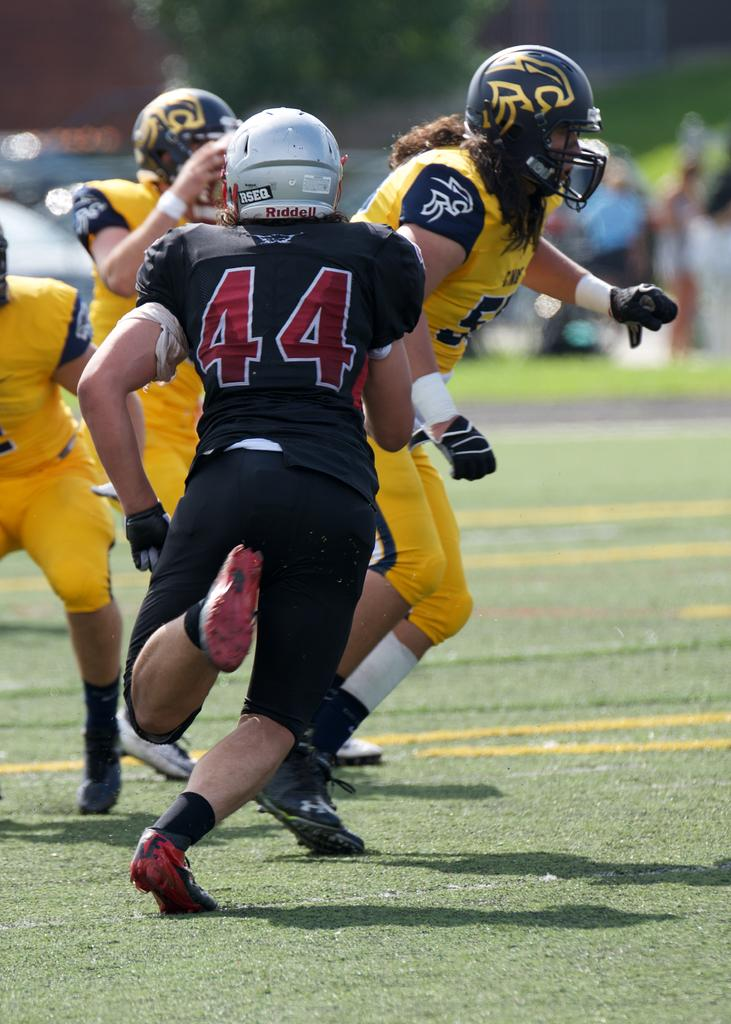What is the main subject of the image? The main subject of the image is people. Where are the people located in the image? The people are in the front of the image. What is the ground surface like where the people are standing? The people are standing on grass. What protective gear are the people wearing? The people are wearing helmets. What can be seen in the background of the image? The background of the image is blurry, but a tree and people are visible. What type of picture is the group of people holding in the image? There is no picture visible in the image; the people are wearing helmets and standing on grass. What is the mode of transportation for the people in the image? The image does not show any mode of transportation; the people are standing on grass. 